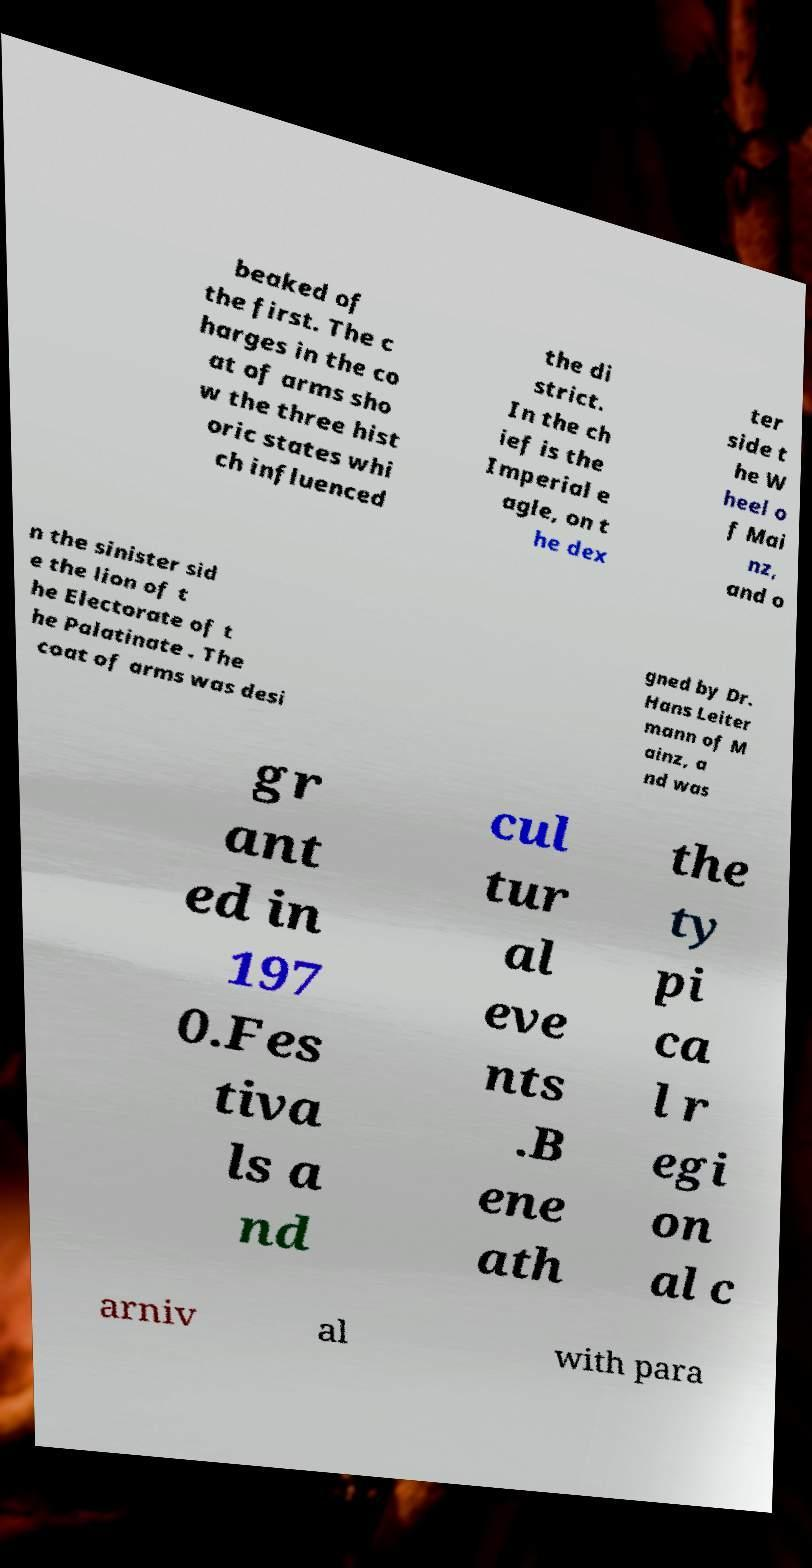Can you accurately transcribe the text from the provided image for me? beaked of the first. The c harges in the co at of arms sho w the three hist oric states whi ch influenced the di strict. In the ch ief is the Imperial e agle, on t he dex ter side t he W heel o f Mai nz, and o n the sinister sid e the lion of t he Electorate of t he Palatinate . The coat of arms was desi gned by Dr. Hans Leiter mann of M ainz, a nd was gr ant ed in 197 0.Fes tiva ls a nd cul tur al eve nts .B ene ath the ty pi ca l r egi on al c arniv al with para 